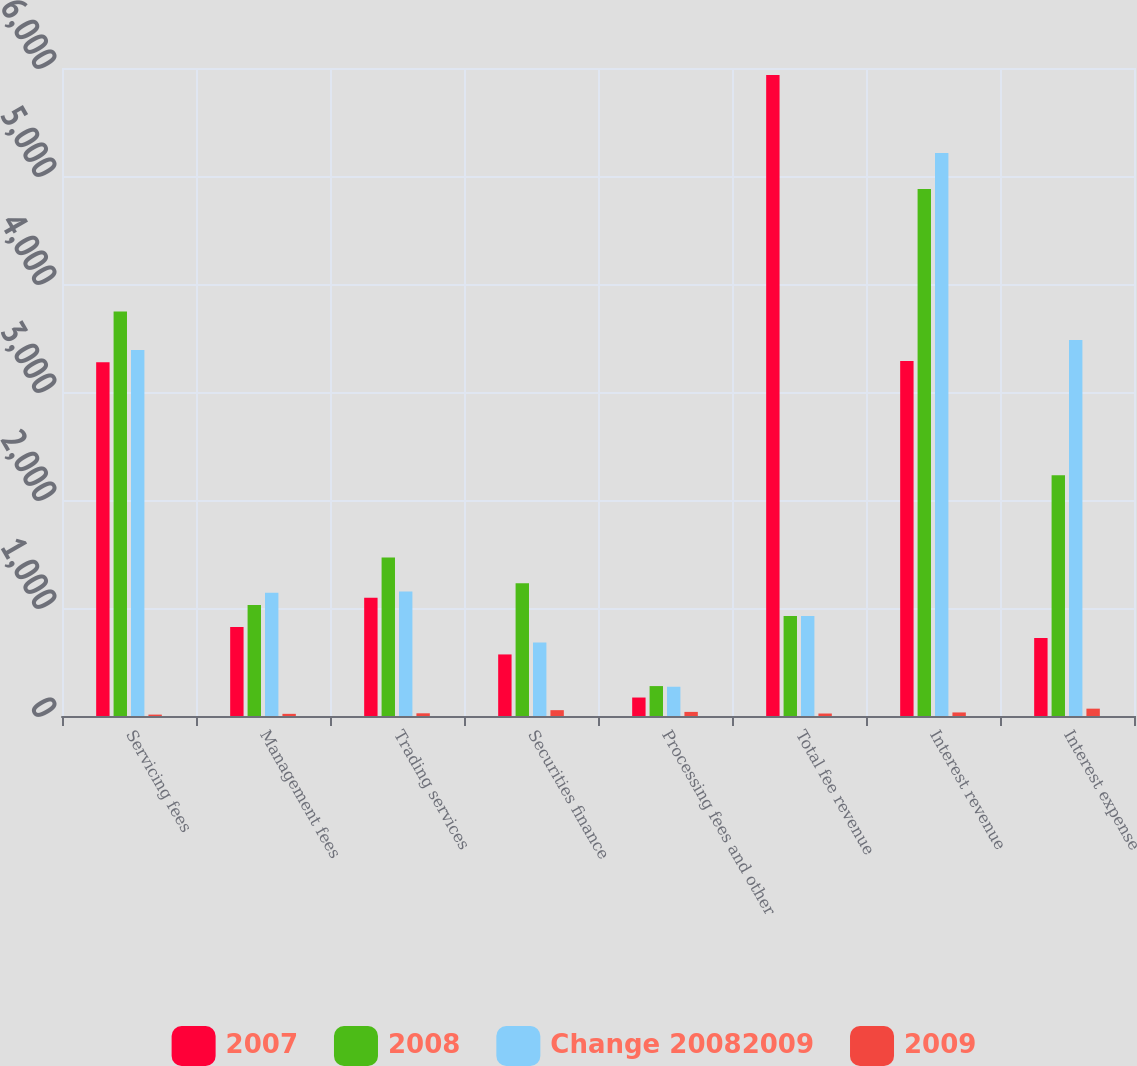<chart> <loc_0><loc_0><loc_500><loc_500><stacked_bar_chart><ecel><fcel>Servicing fees<fcel>Management fees<fcel>Trading services<fcel>Securities finance<fcel>Processing fees and other<fcel>Total fee revenue<fcel>Interest revenue<fcel>Interest expense<nl><fcel>2007<fcel>3276<fcel>824<fcel>1094<fcel>570<fcel>171<fcel>5935<fcel>3286<fcel>722<nl><fcel>2008<fcel>3745<fcel>1028<fcel>1467<fcel>1230<fcel>277<fcel>926<fcel>4879<fcel>2229<nl><fcel>Change 20082009<fcel>3388<fcel>1141<fcel>1152<fcel>681<fcel>271<fcel>926<fcel>5212<fcel>3482<nl><fcel>2009<fcel>13<fcel>20<fcel>25<fcel>54<fcel>38<fcel>23<fcel>33<fcel>68<nl></chart> 